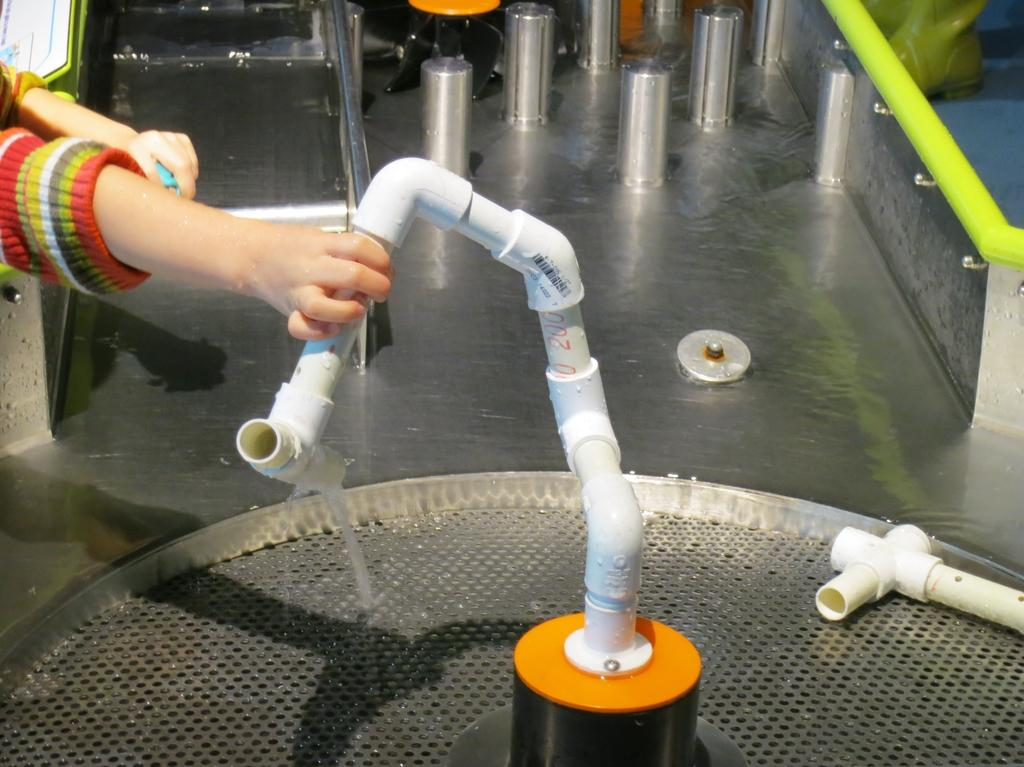Who or what is present in the image? There is a person in the image. What is the person holding in the image? The person is holding a pipe. What can be seen in the background of the image? There are steel rods and water visible in the background of the image. What type of sheet is covering the beetle in the image? There is no beetle or sheet present in the image. What type of plane can be seen flying in the background of the image? There is no plane visible in the image; only steel rods and water are present in the background. 